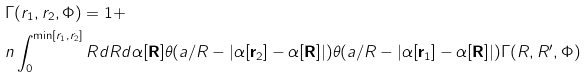Convert formula to latex. <formula><loc_0><loc_0><loc_500><loc_500>& \Gamma ( r _ { 1 } , r _ { 2 } , \Phi ) = 1 + \\ & n \int ^ { \min [ r _ { 1 } , r _ { 2 } ] } _ { 0 } R d R d \alpha [ \mathbf R ] \theta ( a / R - | \alpha [ \mathbf r _ { 2 } ] - \alpha [ \mathbf R ] | ) \theta ( a / R - | \alpha [ \mathbf r _ { 1 } ] - \alpha [ \mathbf R ] | ) \Gamma ( R , R ^ { \prime } , \Phi )</formula> 